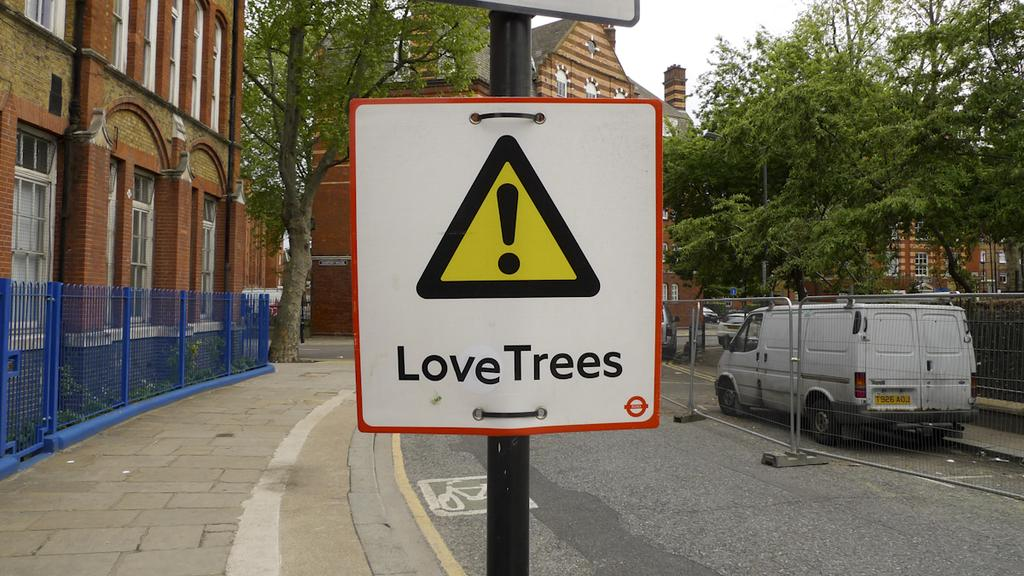<image>
Render a clear and concise summary of the photo. the words love trees on a piece of paper 